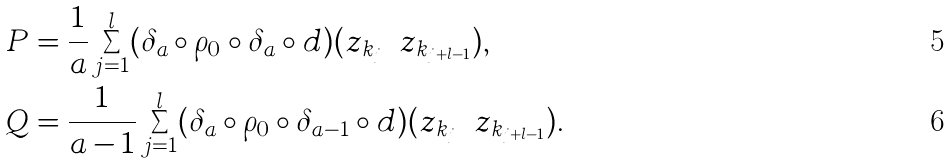Convert formula to latex. <formula><loc_0><loc_0><loc_500><loc_500>P & = \frac { 1 } { a } \sum _ { j = 1 } ^ { l } ( \delta _ { a } \circ \rho _ { 0 } \circ \delta _ { a } \circ d ) ( z _ { k _ { j } } \cdots z _ { k _ { j + l - 1 } } ) , \\ Q & = \frac { 1 } { a - 1 } \sum _ { j = 1 } ^ { l } ( \delta _ { a } \circ \rho _ { 0 } \circ \delta _ { a - 1 } \circ d ) ( z _ { k _ { j } } \cdots z _ { k _ { j + l - 1 } } ) .</formula> 